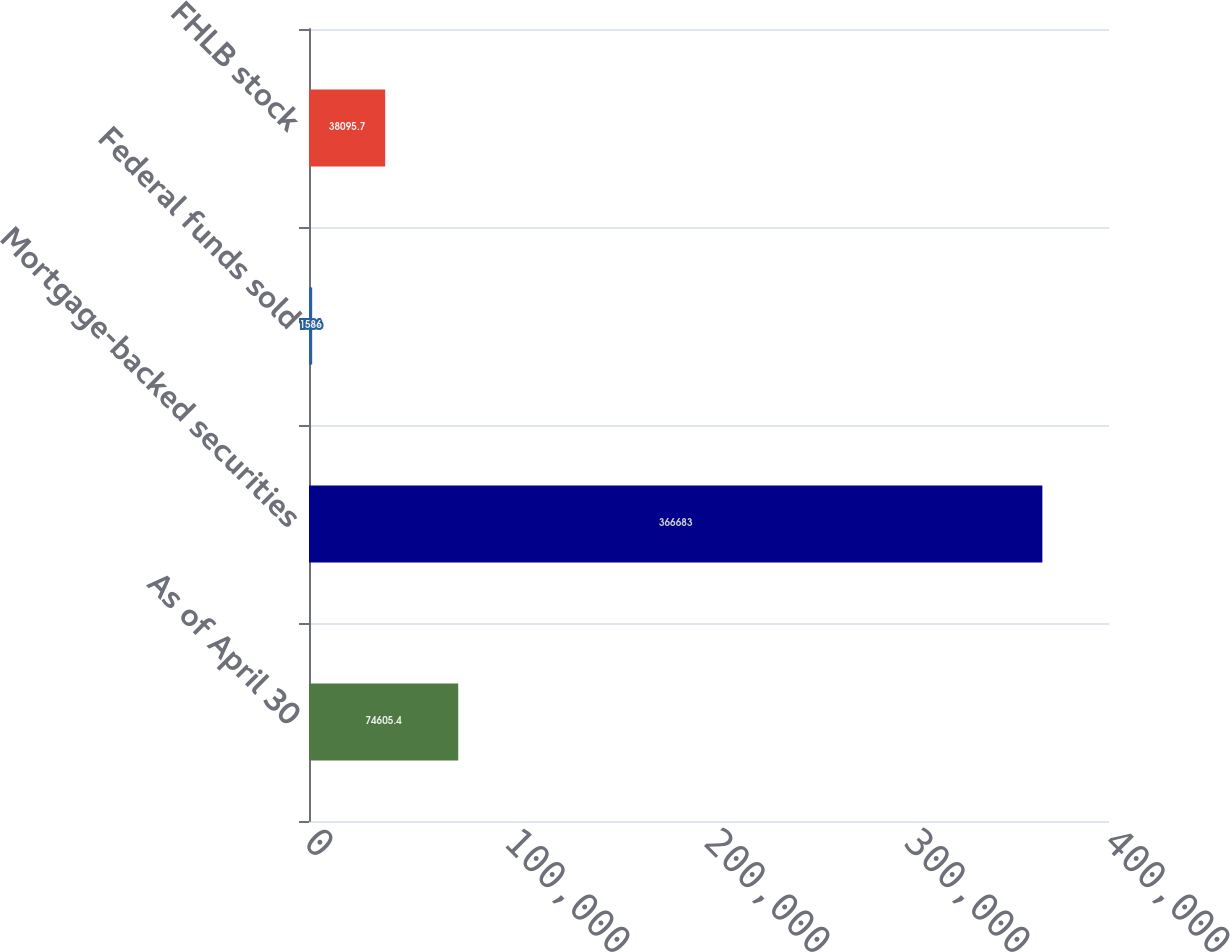Convert chart. <chart><loc_0><loc_0><loc_500><loc_500><bar_chart><fcel>As of April 30<fcel>Mortgage-backed securities<fcel>Federal funds sold<fcel>FHLB stock<nl><fcel>74605.4<fcel>366683<fcel>1586<fcel>38095.7<nl></chart> 